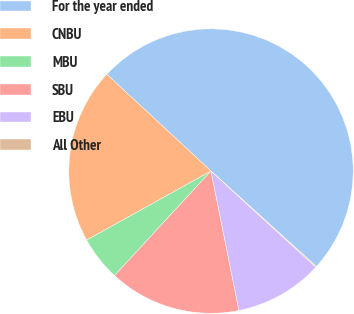Convert chart. <chart><loc_0><loc_0><loc_500><loc_500><pie_chart><fcel>For the year ended<fcel>CNBU<fcel>MBU<fcel>SBU<fcel>EBU<fcel>All Other<nl><fcel>49.8%<fcel>19.98%<fcel>5.07%<fcel>15.01%<fcel>10.04%<fcel>0.1%<nl></chart> 